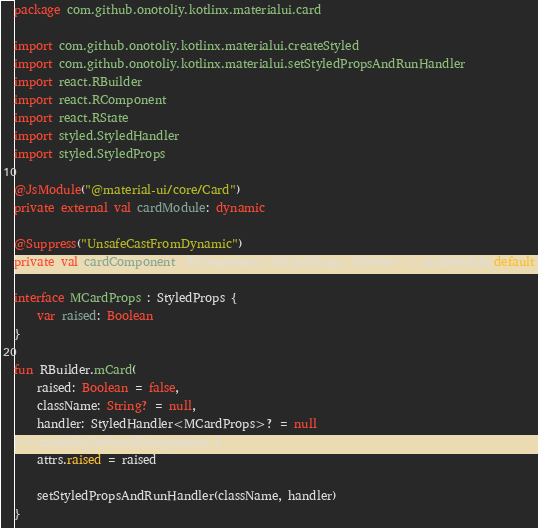<code> <loc_0><loc_0><loc_500><loc_500><_Kotlin_>package com.github.onotoliy.kotlinx.materialui.card

import com.github.onotoliy.kotlinx.materialui.createStyled
import com.github.onotoliy.kotlinx.materialui.setStyledPropsAndRunHandler
import react.RBuilder
import react.RComponent
import react.RState
import styled.StyledHandler
import styled.StyledProps

@JsModule("@material-ui/core/Card")
private external val cardModule: dynamic

@Suppress("UnsafeCastFromDynamic")
private val cardComponent: RComponent<MCardProps, RState> = cardModule.default

interface MCardProps : StyledProps {
    var raised: Boolean
}

fun RBuilder.mCard(
    raised: Boolean = false,
    className: String? = null,
    handler: StyledHandler<MCardProps>? = null
) = createStyled(cardComponent) {
    attrs.raised = raised

    setStyledPropsAndRunHandler(className, handler)
}
</code> 